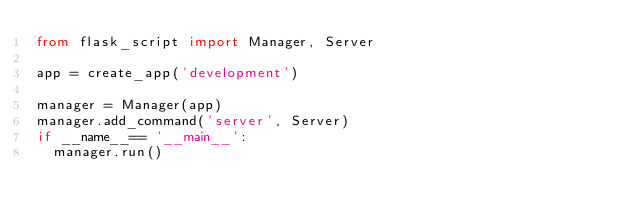Convert code to text. <code><loc_0><loc_0><loc_500><loc_500><_Python_>from flask_script import Manager, Server

app = create_app('development')

manager = Manager(app)
manager.add_command('server', Server)
if __name__== '__main__':
  manager.run()</code> 